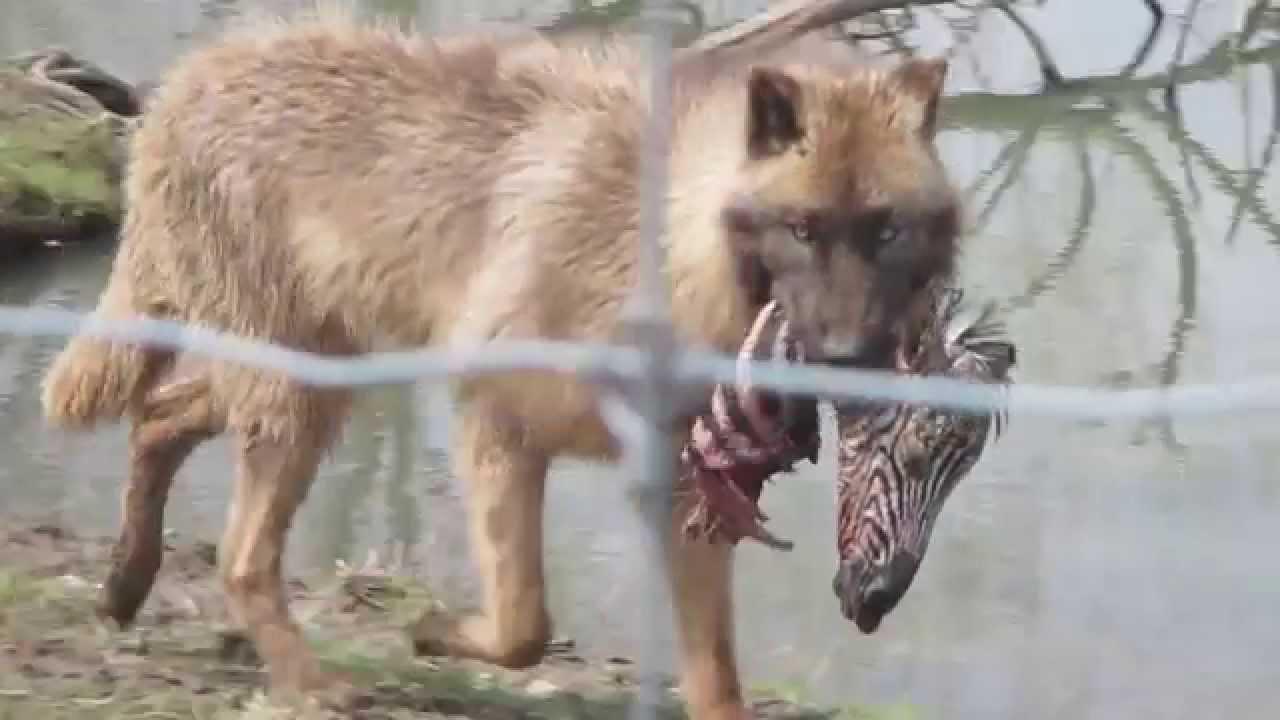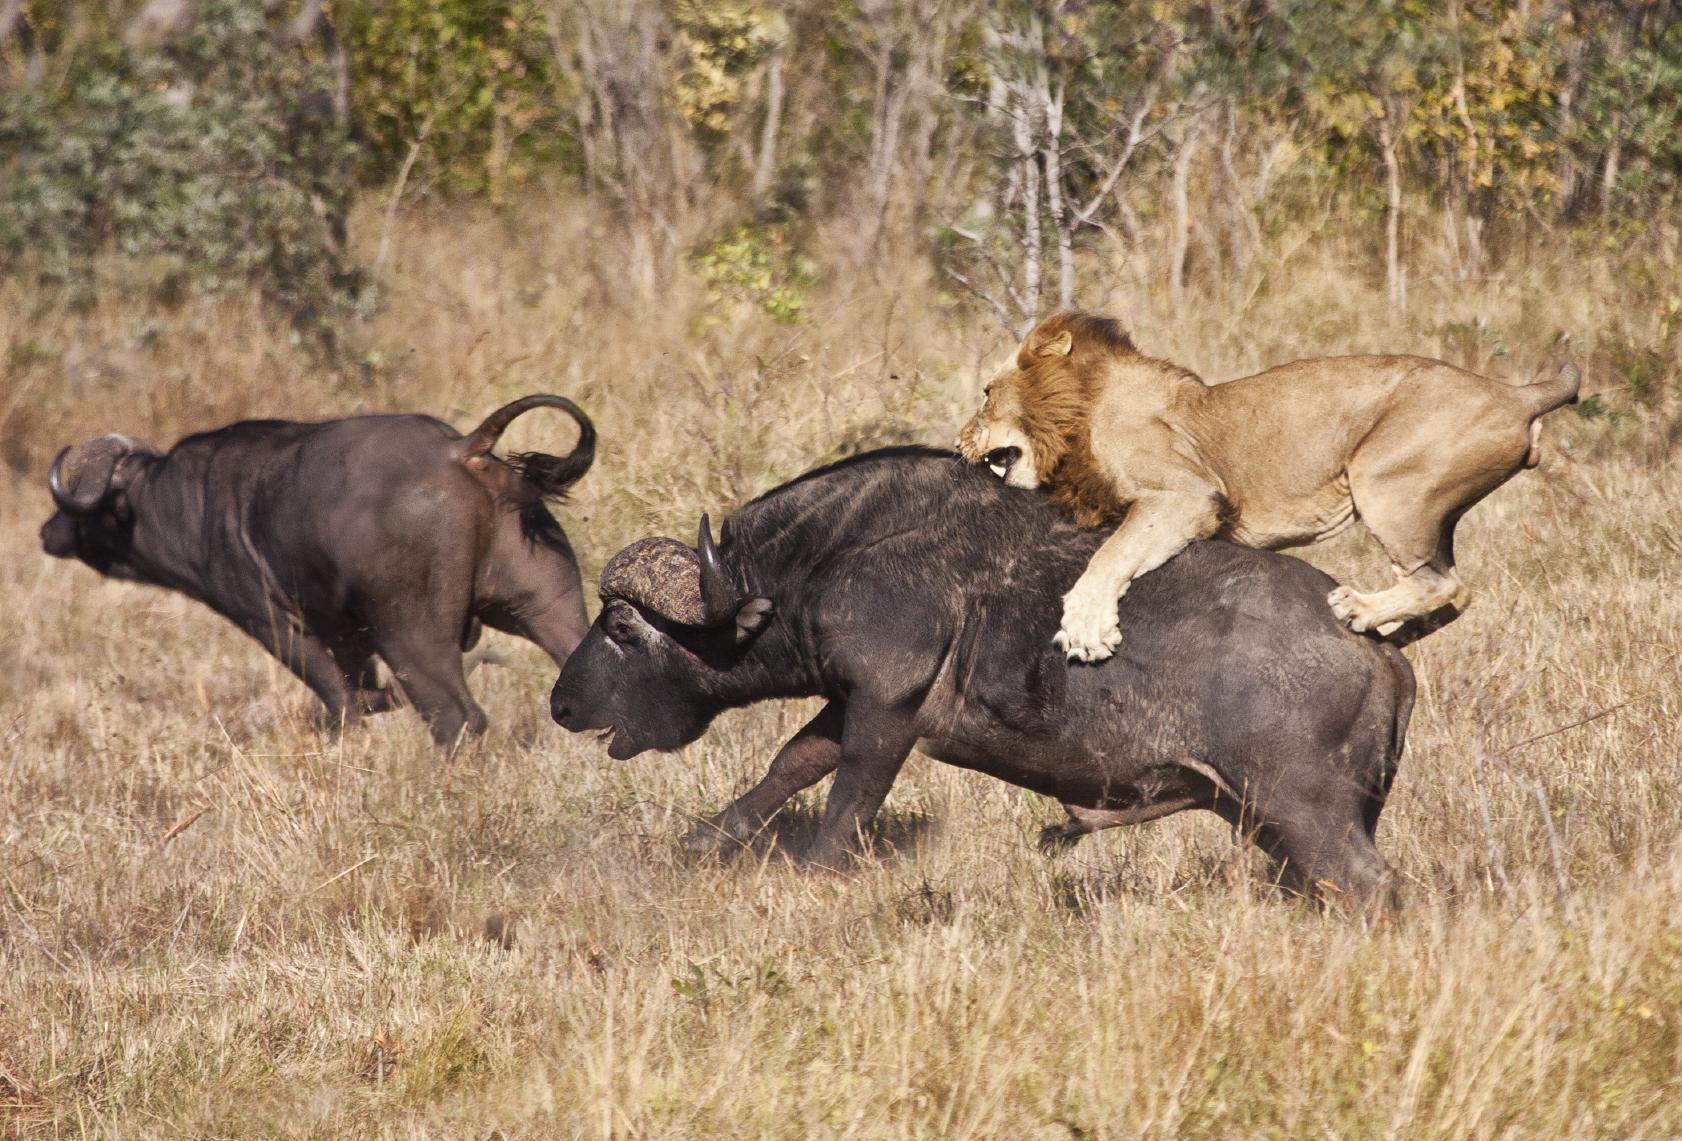The first image is the image on the left, the second image is the image on the right. Examine the images to the left and right. Is the description "Two or more wolves are eating an animal carcass together." accurate? Answer yes or no. No. The first image is the image on the left, the second image is the image on the right. Assess this claim about the two images: "The wild dogs in the image on the right are feeding on their prey.". Correct or not? Answer yes or no. No. 